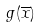<formula> <loc_0><loc_0><loc_500><loc_500>g ( \overline { x } )</formula> 